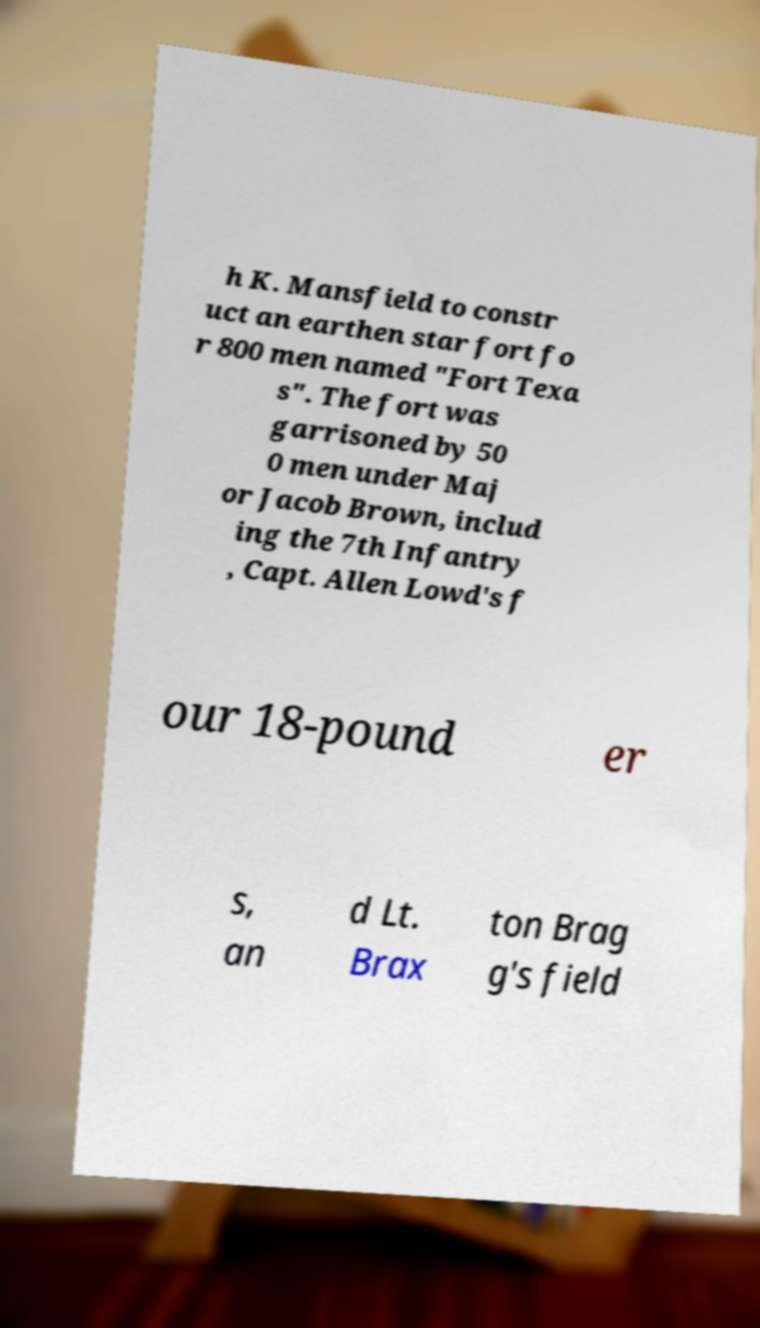For documentation purposes, I need the text within this image transcribed. Could you provide that? h K. Mansfield to constr uct an earthen star fort fo r 800 men named "Fort Texa s". The fort was garrisoned by 50 0 men under Maj or Jacob Brown, includ ing the 7th Infantry , Capt. Allen Lowd's f our 18-pound er s, an d Lt. Brax ton Brag g's field 